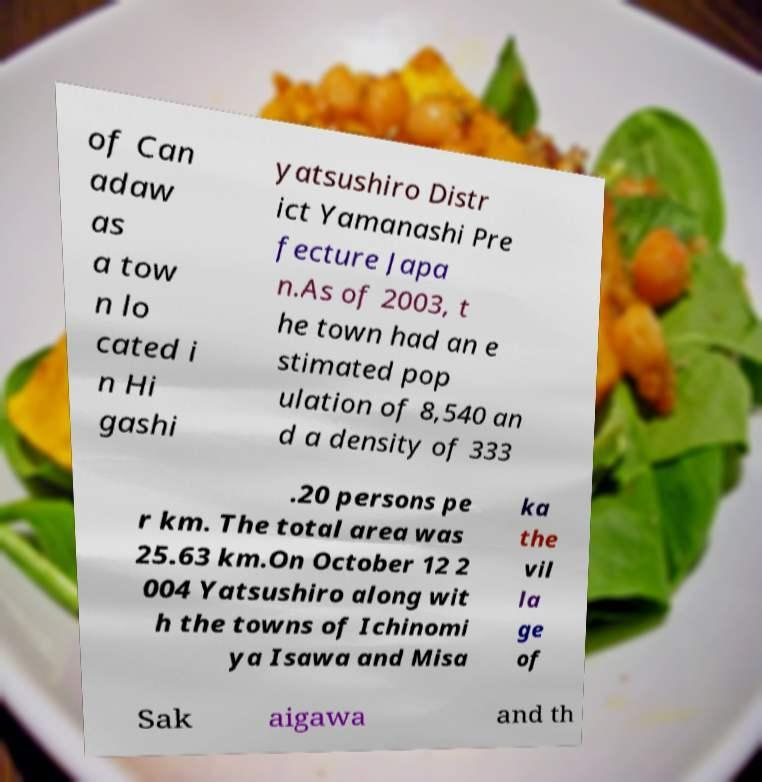Please identify and transcribe the text found in this image. of Can adaw as a tow n lo cated i n Hi gashi yatsushiro Distr ict Yamanashi Pre fecture Japa n.As of 2003, t he town had an e stimated pop ulation of 8,540 an d a density of 333 .20 persons pe r km. The total area was 25.63 km.On October 12 2 004 Yatsushiro along wit h the towns of Ichinomi ya Isawa and Misa ka the vil la ge of Sak aigawa and th 